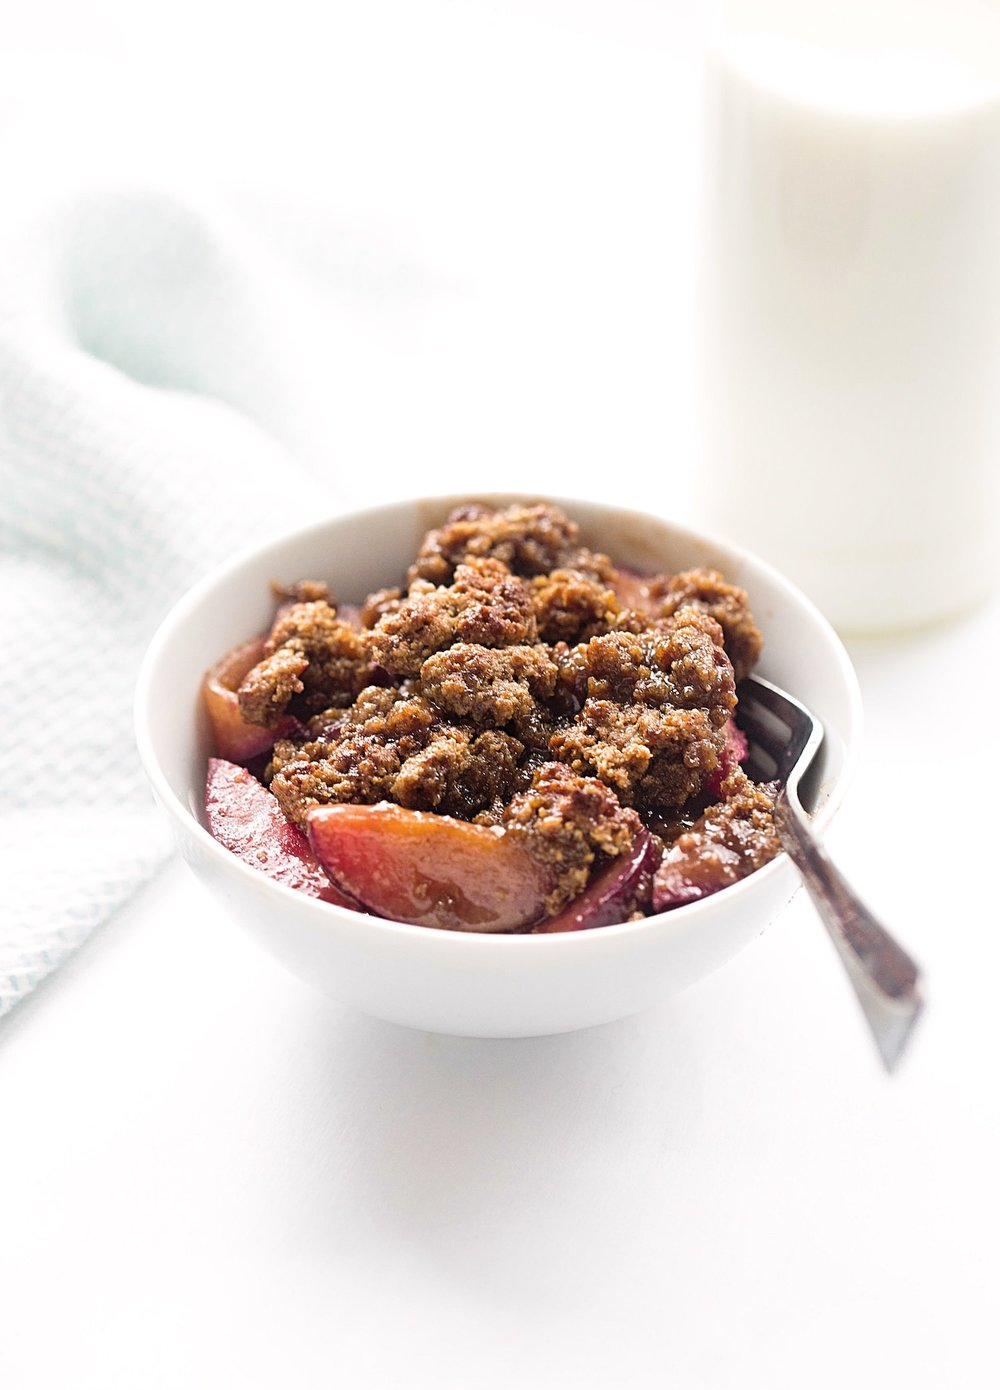Could this dessert have any seasonal variations? Absolutely, the fruit crumble is versatile and can adapt to seasonal fruits. In the summer, a mix of berries or peaches would be divine. During autumn, apples and pears would bring warmth, and in winter, tropical fruits like mango or pineapple could offer a bright twist. 